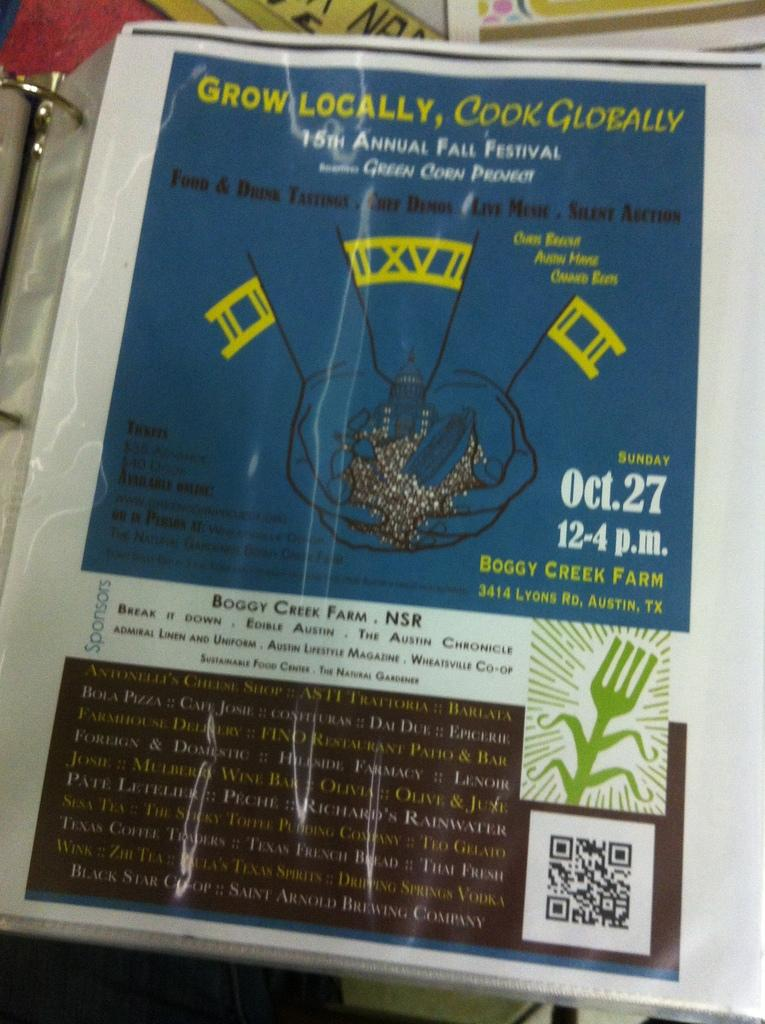<image>
Relay a brief, clear account of the picture shown. A poster for an event on October 27th is titled Grow Locally, Cook Globally. 